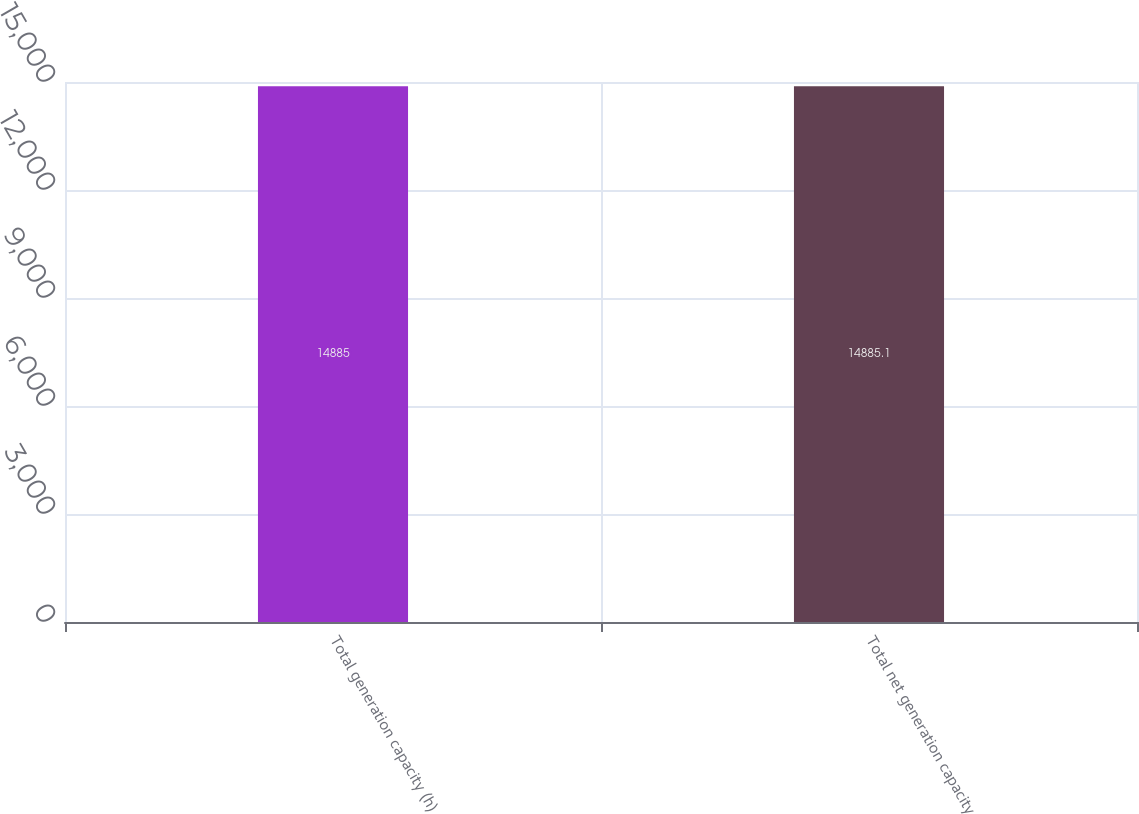<chart> <loc_0><loc_0><loc_500><loc_500><bar_chart><fcel>Total generation capacity (h)<fcel>Total net generation capacity<nl><fcel>14885<fcel>14885.1<nl></chart> 